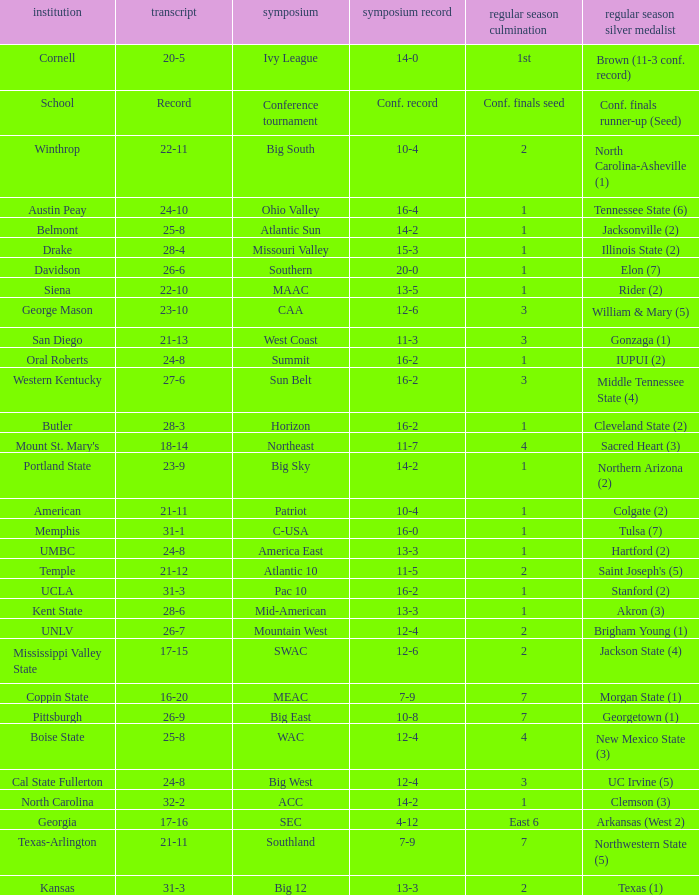Which conference is Belmont in? Atlantic Sun. 